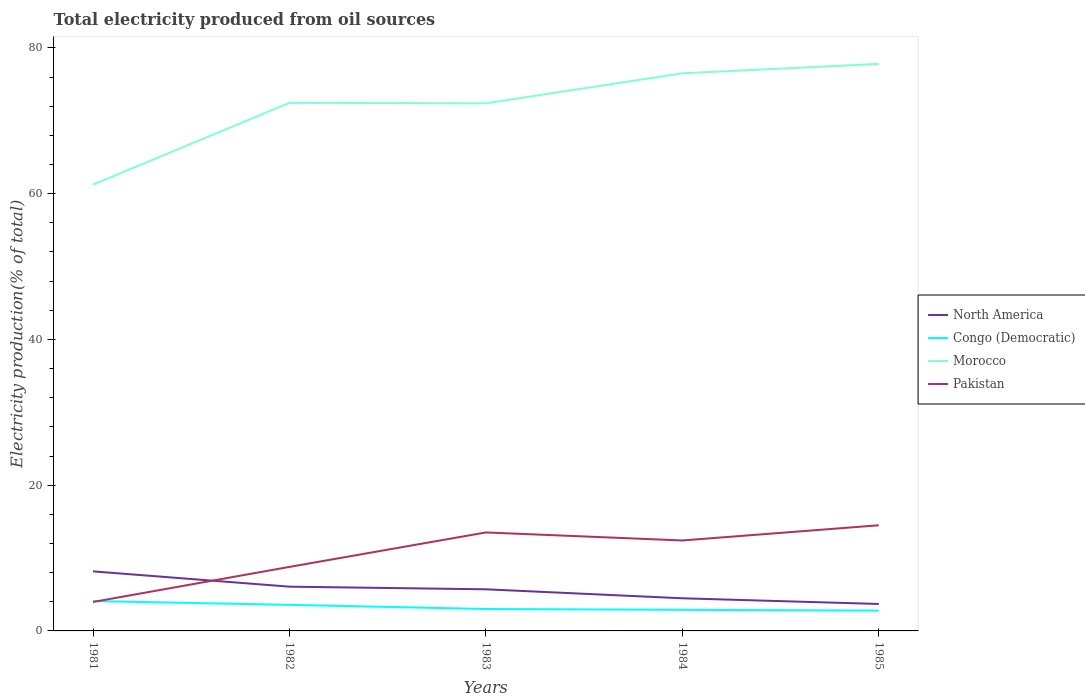Does the line corresponding to Congo (Democratic) intersect with the line corresponding to North America?
Ensure brevity in your answer.  No. Across all years, what is the maximum total electricity produced in North America?
Offer a terse response. 3.7. What is the total total electricity produced in Pakistan in the graph?
Your answer should be very brief. -3.63. What is the difference between the highest and the second highest total electricity produced in Congo (Democratic)?
Make the answer very short. 1.31. What is the difference between the highest and the lowest total electricity produced in Pakistan?
Keep it short and to the point. 3. How many lines are there?
Give a very brief answer. 4. What is the difference between two consecutive major ticks on the Y-axis?
Keep it short and to the point. 20. Does the graph contain any zero values?
Ensure brevity in your answer.  No. Does the graph contain grids?
Ensure brevity in your answer.  No. How many legend labels are there?
Ensure brevity in your answer.  4. What is the title of the graph?
Ensure brevity in your answer.  Total electricity produced from oil sources. Does "Philippines" appear as one of the legend labels in the graph?
Your answer should be very brief. No. What is the Electricity production(% of total) of North America in 1981?
Provide a short and direct response. 8.17. What is the Electricity production(% of total) of Congo (Democratic) in 1981?
Keep it short and to the point. 4.09. What is the Electricity production(% of total) of Morocco in 1981?
Keep it short and to the point. 61.24. What is the Electricity production(% of total) in Pakistan in 1981?
Keep it short and to the point. 3.97. What is the Electricity production(% of total) of North America in 1982?
Keep it short and to the point. 6.07. What is the Electricity production(% of total) in Congo (Democratic) in 1982?
Offer a very short reply. 3.58. What is the Electricity production(% of total) of Morocco in 1982?
Make the answer very short. 72.47. What is the Electricity production(% of total) in Pakistan in 1982?
Keep it short and to the point. 8.79. What is the Electricity production(% of total) in North America in 1983?
Provide a short and direct response. 5.71. What is the Electricity production(% of total) of Congo (Democratic) in 1983?
Provide a short and direct response. 3.01. What is the Electricity production(% of total) in Morocco in 1983?
Keep it short and to the point. 72.41. What is the Electricity production(% of total) in Pakistan in 1983?
Ensure brevity in your answer.  13.51. What is the Electricity production(% of total) of North America in 1984?
Make the answer very short. 4.48. What is the Electricity production(% of total) of Congo (Democratic) in 1984?
Give a very brief answer. 2.9. What is the Electricity production(% of total) of Morocco in 1984?
Provide a short and direct response. 76.52. What is the Electricity production(% of total) in Pakistan in 1984?
Offer a very short reply. 12.41. What is the Electricity production(% of total) of North America in 1985?
Provide a short and direct response. 3.7. What is the Electricity production(% of total) in Congo (Democratic) in 1985?
Provide a succinct answer. 2.78. What is the Electricity production(% of total) in Morocco in 1985?
Provide a short and direct response. 77.81. What is the Electricity production(% of total) in Pakistan in 1985?
Offer a very short reply. 14.5. Across all years, what is the maximum Electricity production(% of total) in North America?
Your answer should be very brief. 8.17. Across all years, what is the maximum Electricity production(% of total) in Congo (Democratic)?
Provide a short and direct response. 4.09. Across all years, what is the maximum Electricity production(% of total) in Morocco?
Give a very brief answer. 77.81. Across all years, what is the maximum Electricity production(% of total) of Pakistan?
Offer a terse response. 14.5. Across all years, what is the minimum Electricity production(% of total) of North America?
Your answer should be very brief. 3.7. Across all years, what is the minimum Electricity production(% of total) in Congo (Democratic)?
Offer a terse response. 2.78. Across all years, what is the minimum Electricity production(% of total) of Morocco?
Provide a succinct answer. 61.24. Across all years, what is the minimum Electricity production(% of total) of Pakistan?
Provide a succinct answer. 3.97. What is the total Electricity production(% of total) in North America in the graph?
Offer a very short reply. 28.14. What is the total Electricity production(% of total) of Congo (Democratic) in the graph?
Your answer should be very brief. 16.36. What is the total Electricity production(% of total) of Morocco in the graph?
Make the answer very short. 360.44. What is the total Electricity production(% of total) in Pakistan in the graph?
Provide a succinct answer. 53.18. What is the difference between the Electricity production(% of total) in North America in 1981 and that in 1982?
Offer a very short reply. 2.1. What is the difference between the Electricity production(% of total) in Congo (Democratic) in 1981 and that in 1982?
Your answer should be very brief. 0.52. What is the difference between the Electricity production(% of total) in Morocco in 1981 and that in 1982?
Make the answer very short. -11.22. What is the difference between the Electricity production(% of total) in Pakistan in 1981 and that in 1982?
Keep it short and to the point. -4.81. What is the difference between the Electricity production(% of total) in North America in 1981 and that in 1983?
Provide a succinct answer. 2.46. What is the difference between the Electricity production(% of total) of Congo (Democratic) in 1981 and that in 1983?
Your answer should be compact. 1.08. What is the difference between the Electricity production(% of total) in Morocco in 1981 and that in 1983?
Your answer should be very brief. -11.16. What is the difference between the Electricity production(% of total) of Pakistan in 1981 and that in 1983?
Keep it short and to the point. -9.54. What is the difference between the Electricity production(% of total) of North America in 1981 and that in 1984?
Your response must be concise. 3.69. What is the difference between the Electricity production(% of total) of Congo (Democratic) in 1981 and that in 1984?
Offer a terse response. 1.2. What is the difference between the Electricity production(% of total) in Morocco in 1981 and that in 1984?
Your answer should be very brief. -15.28. What is the difference between the Electricity production(% of total) in Pakistan in 1981 and that in 1984?
Your response must be concise. -8.44. What is the difference between the Electricity production(% of total) in North America in 1981 and that in 1985?
Make the answer very short. 4.48. What is the difference between the Electricity production(% of total) of Congo (Democratic) in 1981 and that in 1985?
Make the answer very short. 1.31. What is the difference between the Electricity production(% of total) of Morocco in 1981 and that in 1985?
Your response must be concise. -16.57. What is the difference between the Electricity production(% of total) of Pakistan in 1981 and that in 1985?
Provide a short and direct response. -10.53. What is the difference between the Electricity production(% of total) of North America in 1982 and that in 1983?
Your answer should be compact. 0.36. What is the difference between the Electricity production(% of total) in Congo (Democratic) in 1982 and that in 1983?
Offer a very short reply. 0.57. What is the difference between the Electricity production(% of total) of Morocco in 1982 and that in 1983?
Provide a succinct answer. 0.06. What is the difference between the Electricity production(% of total) in Pakistan in 1982 and that in 1983?
Give a very brief answer. -4.73. What is the difference between the Electricity production(% of total) in North America in 1982 and that in 1984?
Provide a succinct answer. 1.59. What is the difference between the Electricity production(% of total) in Congo (Democratic) in 1982 and that in 1984?
Provide a succinct answer. 0.68. What is the difference between the Electricity production(% of total) in Morocco in 1982 and that in 1984?
Your answer should be compact. -4.06. What is the difference between the Electricity production(% of total) of Pakistan in 1982 and that in 1984?
Offer a terse response. -3.63. What is the difference between the Electricity production(% of total) of North America in 1982 and that in 1985?
Offer a terse response. 2.37. What is the difference between the Electricity production(% of total) in Congo (Democratic) in 1982 and that in 1985?
Your answer should be very brief. 0.79. What is the difference between the Electricity production(% of total) of Morocco in 1982 and that in 1985?
Keep it short and to the point. -5.34. What is the difference between the Electricity production(% of total) of Pakistan in 1982 and that in 1985?
Your response must be concise. -5.71. What is the difference between the Electricity production(% of total) in North America in 1983 and that in 1984?
Provide a short and direct response. 1.23. What is the difference between the Electricity production(% of total) in Congo (Democratic) in 1983 and that in 1984?
Provide a succinct answer. 0.11. What is the difference between the Electricity production(% of total) of Morocco in 1983 and that in 1984?
Provide a succinct answer. -4.12. What is the difference between the Electricity production(% of total) of Pakistan in 1983 and that in 1984?
Offer a very short reply. 1.1. What is the difference between the Electricity production(% of total) in North America in 1983 and that in 1985?
Offer a very short reply. 2.01. What is the difference between the Electricity production(% of total) of Congo (Democratic) in 1983 and that in 1985?
Ensure brevity in your answer.  0.23. What is the difference between the Electricity production(% of total) in Morocco in 1983 and that in 1985?
Make the answer very short. -5.4. What is the difference between the Electricity production(% of total) of Pakistan in 1983 and that in 1985?
Ensure brevity in your answer.  -0.98. What is the difference between the Electricity production(% of total) of North America in 1984 and that in 1985?
Your response must be concise. 0.78. What is the difference between the Electricity production(% of total) in Congo (Democratic) in 1984 and that in 1985?
Make the answer very short. 0.11. What is the difference between the Electricity production(% of total) in Morocco in 1984 and that in 1985?
Your answer should be very brief. -1.29. What is the difference between the Electricity production(% of total) of Pakistan in 1984 and that in 1985?
Make the answer very short. -2.09. What is the difference between the Electricity production(% of total) of North America in 1981 and the Electricity production(% of total) of Congo (Democratic) in 1982?
Your answer should be compact. 4.6. What is the difference between the Electricity production(% of total) of North America in 1981 and the Electricity production(% of total) of Morocco in 1982?
Provide a short and direct response. -64.29. What is the difference between the Electricity production(% of total) in North America in 1981 and the Electricity production(% of total) in Pakistan in 1982?
Ensure brevity in your answer.  -0.61. What is the difference between the Electricity production(% of total) of Congo (Democratic) in 1981 and the Electricity production(% of total) of Morocco in 1982?
Offer a very short reply. -68.37. What is the difference between the Electricity production(% of total) in Congo (Democratic) in 1981 and the Electricity production(% of total) in Pakistan in 1982?
Give a very brief answer. -4.69. What is the difference between the Electricity production(% of total) of Morocco in 1981 and the Electricity production(% of total) of Pakistan in 1982?
Give a very brief answer. 52.46. What is the difference between the Electricity production(% of total) in North America in 1981 and the Electricity production(% of total) in Congo (Democratic) in 1983?
Provide a short and direct response. 5.16. What is the difference between the Electricity production(% of total) in North America in 1981 and the Electricity production(% of total) in Morocco in 1983?
Provide a succinct answer. -64.23. What is the difference between the Electricity production(% of total) of North America in 1981 and the Electricity production(% of total) of Pakistan in 1983?
Provide a succinct answer. -5.34. What is the difference between the Electricity production(% of total) in Congo (Democratic) in 1981 and the Electricity production(% of total) in Morocco in 1983?
Your response must be concise. -68.31. What is the difference between the Electricity production(% of total) of Congo (Democratic) in 1981 and the Electricity production(% of total) of Pakistan in 1983?
Ensure brevity in your answer.  -9.42. What is the difference between the Electricity production(% of total) of Morocco in 1981 and the Electricity production(% of total) of Pakistan in 1983?
Provide a succinct answer. 47.73. What is the difference between the Electricity production(% of total) of North America in 1981 and the Electricity production(% of total) of Congo (Democratic) in 1984?
Provide a short and direct response. 5.28. What is the difference between the Electricity production(% of total) in North America in 1981 and the Electricity production(% of total) in Morocco in 1984?
Provide a short and direct response. -68.35. What is the difference between the Electricity production(% of total) of North America in 1981 and the Electricity production(% of total) of Pakistan in 1984?
Give a very brief answer. -4.24. What is the difference between the Electricity production(% of total) of Congo (Democratic) in 1981 and the Electricity production(% of total) of Morocco in 1984?
Give a very brief answer. -72.43. What is the difference between the Electricity production(% of total) of Congo (Democratic) in 1981 and the Electricity production(% of total) of Pakistan in 1984?
Make the answer very short. -8.32. What is the difference between the Electricity production(% of total) in Morocco in 1981 and the Electricity production(% of total) in Pakistan in 1984?
Your answer should be very brief. 48.83. What is the difference between the Electricity production(% of total) in North America in 1981 and the Electricity production(% of total) in Congo (Democratic) in 1985?
Your answer should be compact. 5.39. What is the difference between the Electricity production(% of total) of North America in 1981 and the Electricity production(% of total) of Morocco in 1985?
Ensure brevity in your answer.  -69.63. What is the difference between the Electricity production(% of total) of North America in 1981 and the Electricity production(% of total) of Pakistan in 1985?
Keep it short and to the point. -6.32. What is the difference between the Electricity production(% of total) in Congo (Democratic) in 1981 and the Electricity production(% of total) in Morocco in 1985?
Your response must be concise. -73.71. What is the difference between the Electricity production(% of total) in Congo (Democratic) in 1981 and the Electricity production(% of total) in Pakistan in 1985?
Ensure brevity in your answer.  -10.4. What is the difference between the Electricity production(% of total) of Morocco in 1981 and the Electricity production(% of total) of Pakistan in 1985?
Provide a succinct answer. 46.74. What is the difference between the Electricity production(% of total) of North America in 1982 and the Electricity production(% of total) of Congo (Democratic) in 1983?
Provide a short and direct response. 3.06. What is the difference between the Electricity production(% of total) of North America in 1982 and the Electricity production(% of total) of Morocco in 1983?
Offer a very short reply. -66.33. What is the difference between the Electricity production(% of total) in North America in 1982 and the Electricity production(% of total) in Pakistan in 1983?
Offer a very short reply. -7.44. What is the difference between the Electricity production(% of total) of Congo (Democratic) in 1982 and the Electricity production(% of total) of Morocco in 1983?
Provide a short and direct response. -68.83. What is the difference between the Electricity production(% of total) in Congo (Democratic) in 1982 and the Electricity production(% of total) in Pakistan in 1983?
Make the answer very short. -9.94. What is the difference between the Electricity production(% of total) in Morocco in 1982 and the Electricity production(% of total) in Pakistan in 1983?
Your answer should be compact. 58.95. What is the difference between the Electricity production(% of total) in North America in 1982 and the Electricity production(% of total) in Congo (Democratic) in 1984?
Offer a terse response. 3.18. What is the difference between the Electricity production(% of total) in North America in 1982 and the Electricity production(% of total) in Morocco in 1984?
Your answer should be compact. -70.45. What is the difference between the Electricity production(% of total) in North America in 1982 and the Electricity production(% of total) in Pakistan in 1984?
Provide a succinct answer. -6.34. What is the difference between the Electricity production(% of total) in Congo (Democratic) in 1982 and the Electricity production(% of total) in Morocco in 1984?
Ensure brevity in your answer.  -72.94. What is the difference between the Electricity production(% of total) in Congo (Democratic) in 1982 and the Electricity production(% of total) in Pakistan in 1984?
Offer a terse response. -8.83. What is the difference between the Electricity production(% of total) in Morocco in 1982 and the Electricity production(% of total) in Pakistan in 1984?
Keep it short and to the point. 60.05. What is the difference between the Electricity production(% of total) in North America in 1982 and the Electricity production(% of total) in Congo (Democratic) in 1985?
Give a very brief answer. 3.29. What is the difference between the Electricity production(% of total) of North America in 1982 and the Electricity production(% of total) of Morocco in 1985?
Provide a short and direct response. -71.73. What is the difference between the Electricity production(% of total) of North America in 1982 and the Electricity production(% of total) of Pakistan in 1985?
Your answer should be compact. -8.42. What is the difference between the Electricity production(% of total) of Congo (Democratic) in 1982 and the Electricity production(% of total) of Morocco in 1985?
Ensure brevity in your answer.  -74.23. What is the difference between the Electricity production(% of total) of Congo (Democratic) in 1982 and the Electricity production(% of total) of Pakistan in 1985?
Give a very brief answer. -10.92. What is the difference between the Electricity production(% of total) of Morocco in 1982 and the Electricity production(% of total) of Pakistan in 1985?
Your answer should be compact. 57.97. What is the difference between the Electricity production(% of total) of North America in 1983 and the Electricity production(% of total) of Congo (Democratic) in 1984?
Offer a terse response. 2.82. What is the difference between the Electricity production(% of total) of North America in 1983 and the Electricity production(% of total) of Morocco in 1984?
Provide a short and direct response. -70.81. What is the difference between the Electricity production(% of total) of North America in 1983 and the Electricity production(% of total) of Pakistan in 1984?
Give a very brief answer. -6.7. What is the difference between the Electricity production(% of total) of Congo (Democratic) in 1983 and the Electricity production(% of total) of Morocco in 1984?
Offer a terse response. -73.51. What is the difference between the Electricity production(% of total) of Congo (Democratic) in 1983 and the Electricity production(% of total) of Pakistan in 1984?
Offer a very short reply. -9.4. What is the difference between the Electricity production(% of total) of Morocco in 1983 and the Electricity production(% of total) of Pakistan in 1984?
Provide a short and direct response. 59.99. What is the difference between the Electricity production(% of total) of North America in 1983 and the Electricity production(% of total) of Congo (Democratic) in 1985?
Your response must be concise. 2.93. What is the difference between the Electricity production(% of total) of North America in 1983 and the Electricity production(% of total) of Morocco in 1985?
Make the answer very short. -72.1. What is the difference between the Electricity production(% of total) of North America in 1983 and the Electricity production(% of total) of Pakistan in 1985?
Your response must be concise. -8.79. What is the difference between the Electricity production(% of total) of Congo (Democratic) in 1983 and the Electricity production(% of total) of Morocco in 1985?
Make the answer very short. -74.8. What is the difference between the Electricity production(% of total) in Congo (Democratic) in 1983 and the Electricity production(% of total) in Pakistan in 1985?
Provide a short and direct response. -11.49. What is the difference between the Electricity production(% of total) in Morocco in 1983 and the Electricity production(% of total) in Pakistan in 1985?
Ensure brevity in your answer.  57.91. What is the difference between the Electricity production(% of total) of North America in 1984 and the Electricity production(% of total) of Congo (Democratic) in 1985?
Make the answer very short. 1.7. What is the difference between the Electricity production(% of total) in North America in 1984 and the Electricity production(% of total) in Morocco in 1985?
Make the answer very short. -73.33. What is the difference between the Electricity production(% of total) in North America in 1984 and the Electricity production(% of total) in Pakistan in 1985?
Your answer should be compact. -10.02. What is the difference between the Electricity production(% of total) of Congo (Democratic) in 1984 and the Electricity production(% of total) of Morocco in 1985?
Make the answer very short. -74.91. What is the difference between the Electricity production(% of total) of Congo (Democratic) in 1984 and the Electricity production(% of total) of Pakistan in 1985?
Offer a very short reply. -11.6. What is the difference between the Electricity production(% of total) in Morocco in 1984 and the Electricity production(% of total) in Pakistan in 1985?
Offer a terse response. 62.02. What is the average Electricity production(% of total) in North America per year?
Ensure brevity in your answer.  5.63. What is the average Electricity production(% of total) in Congo (Democratic) per year?
Your response must be concise. 3.27. What is the average Electricity production(% of total) of Morocco per year?
Ensure brevity in your answer.  72.09. What is the average Electricity production(% of total) of Pakistan per year?
Your answer should be compact. 10.64. In the year 1981, what is the difference between the Electricity production(% of total) of North America and Electricity production(% of total) of Congo (Democratic)?
Provide a succinct answer. 4.08. In the year 1981, what is the difference between the Electricity production(% of total) of North America and Electricity production(% of total) of Morocco?
Offer a very short reply. -53.07. In the year 1981, what is the difference between the Electricity production(% of total) of North America and Electricity production(% of total) of Pakistan?
Keep it short and to the point. 4.2. In the year 1981, what is the difference between the Electricity production(% of total) of Congo (Democratic) and Electricity production(% of total) of Morocco?
Your answer should be very brief. -57.15. In the year 1981, what is the difference between the Electricity production(% of total) of Congo (Democratic) and Electricity production(% of total) of Pakistan?
Your answer should be compact. 0.12. In the year 1981, what is the difference between the Electricity production(% of total) of Morocco and Electricity production(% of total) of Pakistan?
Offer a very short reply. 57.27. In the year 1982, what is the difference between the Electricity production(% of total) in North America and Electricity production(% of total) in Congo (Democratic)?
Keep it short and to the point. 2.5. In the year 1982, what is the difference between the Electricity production(% of total) in North America and Electricity production(% of total) in Morocco?
Your answer should be very brief. -66.39. In the year 1982, what is the difference between the Electricity production(% of total) in North America and Electricity production(% of total) in Pakistan?
Provide a succinct answer. -2.71. In the year 1982, what is the difference between the Electricity production(% of total) in Congo (Democratic) and Electricity production(% of total) in Morocco?
Give a very brief answer. -68.89. In the year 1982, what is the difference between the Electricity production(% of total) of Congo (Democratic) and Electricity production(% of total) of Pakistan?
Ensure brevity in your answer.  -5.21. In the year 1982, what is the difference between the Electricity production(% of total) in Morocco and Electricity production(% of total) in Pakistan?
Ensure brevity in your answer.  63.68. In the year 1983, what is the difference between the Electricity production(% of total) in North America and Electricity production(% of total) in Congo (Democratic)?
Provide a succinct answer. 2.7. In the year 1983, what is the difference between the Electricity production(% of total) of North America and Electricity production(% of total) of Morocco?
Give a very brief answer. -66.69. In the year 1983, what is the difference between the Electricity production(% of total) of North America and Electricity production(% of total) of Pakistan?
Provide a short and direct response. -7.8. In the year 1983, what is the difference between the Electricity production(% of total) of Congo (Democratic) and Electricity production(% of total) of Morocco?
Keep it short and to the point. -69.4. In the year 1983, what is the difference between the Electricity production(% of total) in Congo (Democratic) and Electricity production(% of total) in Pakistan?
Give a very brief answer. -10.5. In the year 1983, what is the difference between the Electricity production(% of total) in Morocco and Electricity production(% of total) in Pakistan?
Keep it short and to the point. 58.89. In the year 1984, what is the difference between the Electricity production(% of total) of North America and Electricity production(% of total) of Congo (Democratic)?
Provide a short and direct response. 1.58. In the year 1984, what is the difference between the Electricity production(% of total) of North America and Electricity production(% of total) of Morocco?
Provide a succinct answer. -72.04. In the year 1984, what is the difference between the Electricity production(% of total) of North America and Electricity production(% of total) of Pakistan?
Ensure brevity in your answer.  -7.93. In the year 1984, what is the difference between the Electricity production(% of total) of Congo (Democratic) and Electricity production(% of total) of Morocco?
Make the answer very short. -73.63. In the year 1984, what is the difference between the Electricity production(% of total) of Congo (Democratic) and Electricity production(% of total) of Pakistan?
Your answer should be very brief. -9.52. In the year 1984, what is the difference between the Electricity production(% of total) of Morocco and Electricity production(% of total) of Pakistan?
Provide a short and direct response. 64.11. In the year 1985, what is the difference between the Electricity production(% of total) in North America and Electricity production(% of total) in Congo (Democratic)?
Offer a very short reply. 0.91. In the year 1985, what is the difference between the Electricity production(% of total) of North America and Electricity production(% of total) of Morocco?
Your answer should be compact. -74.11. In the year 1985, what is the difference between the Electricity production(% of total) in North America and Electricity production(% of total) in Pakistan?
Offer a terse response. -10.8. In the year 1985, what is the difference between the Electricity production(% of total) in Congo (Democratic) and Electricity production(% of total) in Morocco?
Keep it short and to the point. -75.02. In the year 1985, what is the difference between the Electricity production(% of total) of Congo (Democratic) and Electricity production(% of total) of Pakistan?
Your response must be concise. -11.71. In the year 1985, what is the difference between the Electricity production(% of total) of Morocco and Electricity production(% of total) of Pakistan?
Provide a short and direct response. 63.31. What is the ratio of the Electricity production(% of total) in North America in 1981 to that in 1982?
Ensure brevity in your answer.  1.35. What is the ratio of the Electricity production(% of total) of Congo (Democratic) in 1981 to that in 1982?
Your answer should be compact. 1.14. What is the ratio of the Electricity production(% of total) in Morocco in 1981 to that in 1982?
Provide a short and direct response. 0.85. What is the ratio of the Electricity production(% of total) in Pakistan in 1981 to that in 1982?
Offer a terse response. 0.45. What is the ratio of the Electricity production(% of total) in North America in 1981 to that in 1983?
Your answer should be compact. 1.43. What is the ratio of the Electricity production(% of total) of Congo (Democratic) in 1981 to that in 1983?
Keep it short and to the point. 1.36. What is the ratio of the Electricity production(% of total) of Morocco in 1981 to that in 1983?
Your answer should be compact. 0.85. What is the ratio of the Electricity production(% of total) of Pakistan in 1981 to that in 1983?
Your answer should be very brief. 0.29. What is the ratio of the Electricity production(% of total) in North America in 1981 to that in 1984?
Ensure brevity in your answer.  1.82. What is the ratio of the Electricity production(% of total) of Congo (Democratic) in 1981 to that in 1984?
Keep it short and to the point. 1.41. What is the ratio of the Electricity production(% of total) of Morocco in 1981 to that in 1984?
Give a very brief answer. 0.8. What is the ratio of the Electricity production(% of total) in Pakistan in 1981 to that in 1984?
Offer a very short reply. 0.32. What is the ratio of the Electricity production(% of total) in North America in 1981 to that in 1985?
Provide a succinct answer. 2.21. What is the ratio of the Electricity production(% of total) in Congo (Democratic) in 1981 to that in 1985?
Your answer should be compact. 1.47. What is the ratio of the Electricity production(% of total) in Morocco in 1981 to that in 1985?
Offer a very short reply. 0.79. What is the ratio of the Electricity production(% of total) in Pakistan in 1981 to that in 1985?
Offer a very short reply. 0.27. What is the ratio of the Electricity production(% of total) in North America in 1982 to that in 1983?
Your answer should be compact. 1.06. What is the ratio of the Electricity production(% of total) of Congo (Democratic) in 1982 to that in 1983?
Your answer should be compact. 1.19. What is the ratio of the Electricity production(% of total) in Pakistan in 1982 to that in 1983?
Ensure brevity in your answer.  0.65. What is the ratio of the Electricity production(% of total) in North America in 1982 to that in 1984?
Make the answer very short. 1.36. What is the ratio of the Electricity production(% of total) of Congo (Democratic) in 1982 to that in 1984?
Make the answer very short. 1.24. What is the ratio of the Electricity production(% of total) of Morocco in 1982 to that in 1984?
Your answer should be very brief. 0.95. What is the ratio of the Electricity production(% of total) in Pakistan in 1982 to that in 1984?
Give a very brief answer. 0.71. What is the ratio of the Electricity production(% of total) in North America in 1982 to that in 1985?
Provide a succinct answer. 1.64. What is the ratio of the Electricity production(% of total) of Congo (Democratic) in 1982 to that in 1985?
Offer a very short reply. 1.28. What is the ratio of the Electricity production(% of total) in Morocco in 1982 to that in 1985?
Your answer should be compact. 0.93. What is the ratio of the Electricity production(% of total) of Pakistan in 1982 to that in 1985?
Provide a succinct answer. 0.61. What is the ratio of the Electricity production(% of total) of North America in 1983 to that in 1984?
Give a very brief answer. 1.27. What is the ratio of the Electricity production(% of total) of Congo (Democratic) in 1983 to that in 1984?
Offer a very short reply. 1.04. What is the ratio of the Electricity production(% of total) in Morocco in 1983 to that in 1984?
Your response must be concise. 0.95. What is the ratio of the Electricity production(% of total) of Pakistan in 1983 to that in 1984?
Offer a very short reply. 1.09. What is the ratio of the Electricity production(% of total) in North America in 1983 to that in 1985?
Make the answer very short. 1.54. What is the ratio of the Electricity production(% of total) of Congo (Democratic) in 1983 to that in 1985?
Ensure brevity in your answer.  1.08. What is the ratio of the Electricity production(% of total) of Morocco in 1983 to that in 1985?
Give a very brief answer. 0.93. What is the ratio of the Electricity production(% of total) in Pakistan in 1983 to that in 1985?
Offer a very short reply. 0.93. What is the ratio of the Electricity production(% of total) in North America in 1984 to that in 1985?
Your answer should be very brief. 1.21. What is the ratio of the Electricity production(% of total) of Congo (Democratic) in 1984 to that in 1985?
Offer a terse response. 1.04. What is the ratio of the Electricity production(% of total) in Morocco in 1984 to that in 1985?
Give a very brief answer. 0.98. What is the ratio of the Electricity production(% of total) in Pakistan in 1984 to that in 1985?
Keep it short and to the point. 0.86. What is the difference between the highest and the second highest Electricity production(% of total) in North America?
Ensure brevity in your answer.  2.1. What is the difference between the highest and the second highest Electricity production(% of total) in Congo (Democratic)?
Provide a succinct answer. 0.52. What is the difference between the highest and the second highest Electricity production(% of total) in Morocco?
Your answer should be very brief. 1.29. What is the difference between the highest and the second highest Electricity production(% of total) of Pakistan?
Make the answer very short. 0.98. What is the difference between the highest and the lowest Electricity production(% of total) in North America?
Ensure brevity in your answer.  4.48. What is the difference between the highest and the lowest Electricity production(% of total) in Congo (Democratic)?
Make the answer very short. 1.31. What is the difference between the highest and the lowest Electricity production(% of total) of Morocco?
Offer a very short reply. 16.57. What is the difference between the highest and the lowest Electricity production(% of total) in Pakistan?
Keep it short and to the point. 10.53. 